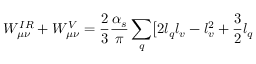<formula> <loc_0><loc_0><loc_500><loc_500>W _ { \mu \nu } ^ { I R } + W _ { \mu \nu } ^ { V } = \frac { 2 } { 3 } \frac { \alpha _ { s } } { \pi } \sum _ { q } \Big [ 2 l _ { q } l _ { v } - l _ { v } ^ { 2 } + \frac { 3 } { 2 } l _ { q }</formula> 